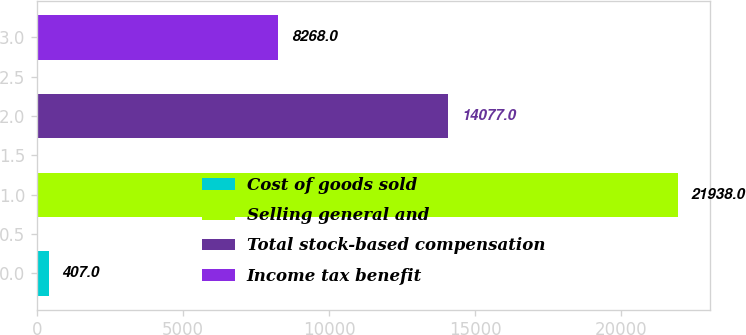Convert chart. <chart><loc_0><loc_0><loc_500><loc_500><bar_chart><fcel>Cost of goods sold<fcel>Selling general and<fcel>Total stock-based compensation<fcel>Income tax benefit<nl><fcel>407<fcel>21938<fcel>14077<fcel>8268<nl></chart> 